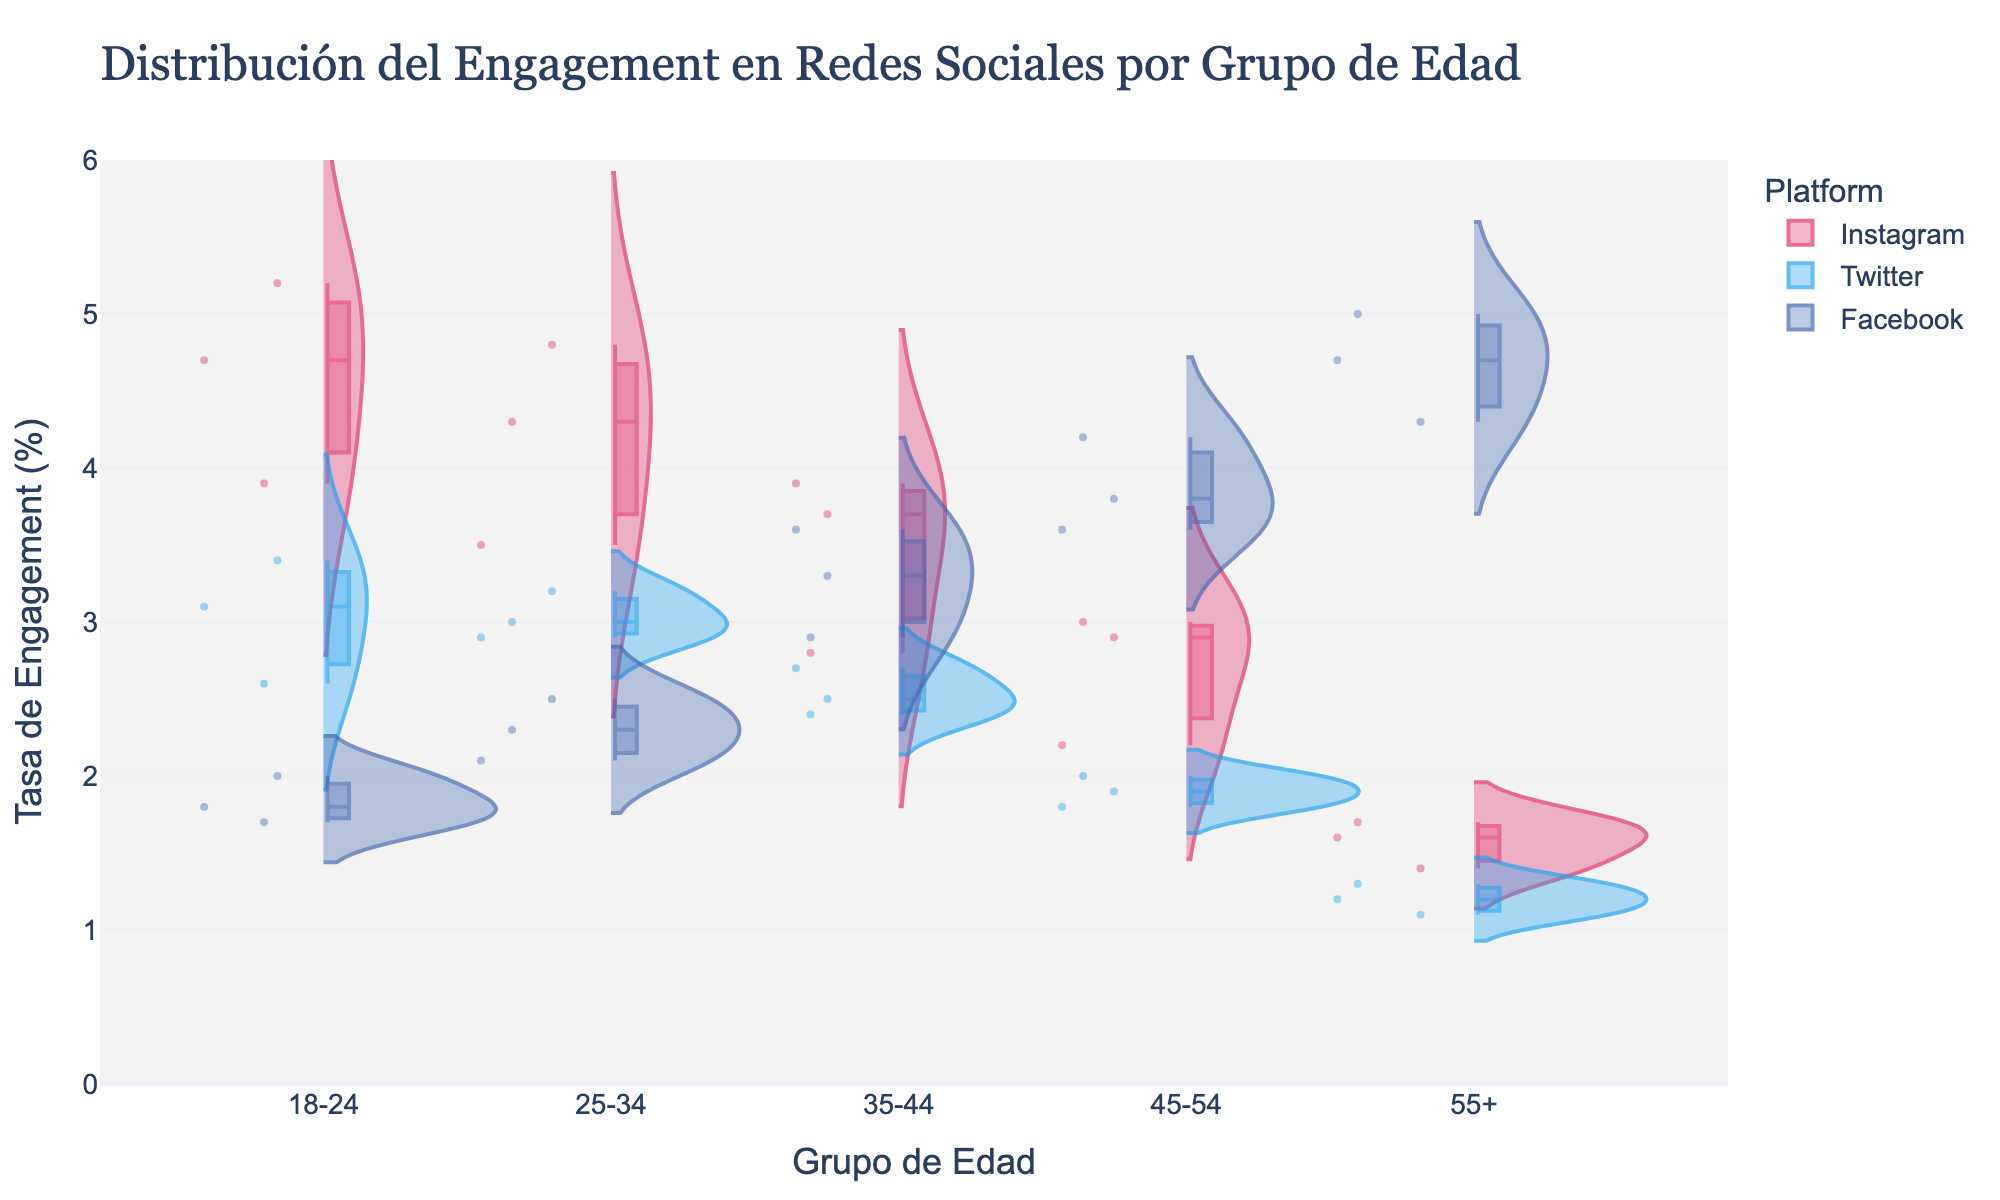What is the title of the figure? The title of the figure is located at the top and usually summarizes the visual information provided. The title here is "Distribución del Engagement en Redes Sociales por Grupo de Edad."
Answer: Distribución del Engagement en Redes Sociales por Grupo de Edad Which platform has the highest engagement rate for the age group 18-24? By observing the violin plots for the age group 18-24, we see that the Instagram platform shows the highest engagement rates when compared with Twitter and Facebook.
Answer: Instagram How does the engagement rate for Facebook vary across different age groups? The violin plot for Facebook engagement rates shows that as the age group increases, the engagement rate also increases, peaking in the 55+ age group.
Answer: Increases with age Which age group has the lowest engagement rate on Instagram? By comparing the height of the violin plots for Instagram across different age groups, the shortest plot corresponds to the 55+ age group, indicating the lowest engagement rate.
Answer: 55+ What is the range of engagement rates for Twitter in the age group 25-34? The violin plot for Twitter in the 25-34 age group shows data points ranging from the lowest at 2.9% to the highest at 3.2%.
Answer: 2.9% to 3.2% Is the engagement rate on Instagram higher than on Twitter for the age group 45-54? Comparing the violin plots for Instagram and Twitter within the 45-54 age group, the Instagram plot is higher, indicating that the engagement rate is higher on Instagram than on Twitter.
Answer: Yes For the age group 35-44, which platform has the most spread in engagement rate? The spread or width of the violin plots shows the variation in engagement rates. For the age group 35-44, Facebook has the widest plot, indicating the most spread in engagement rate.
Answer: Facebook What is the most common engagement rate for Instagram across all age groups? The peaks of the violin plots for Instagram across all age groups indicate the most common engagement rates. For Instagram, these peaks generally appear around 3.0% to 4.8%.
Answer: 3.0% to 4.8% Compare the Facebook engagement rates between the age group 18-24 and 55+. By examining the violin plots for Facebook in the 18-24 and 55+ age groups, we see that the engagement rate is much higher in the 55+ age group compared to the 18-24 age group.
Answer: Higher for 55+ Which platform shows the least variation in engagement rates across the different age groups? Observing the violins for all platforms, Twitter exhibits the least variation in the width of its plots across different age groups, indicating the least variation in engagement rates.
Answer: Twitter 